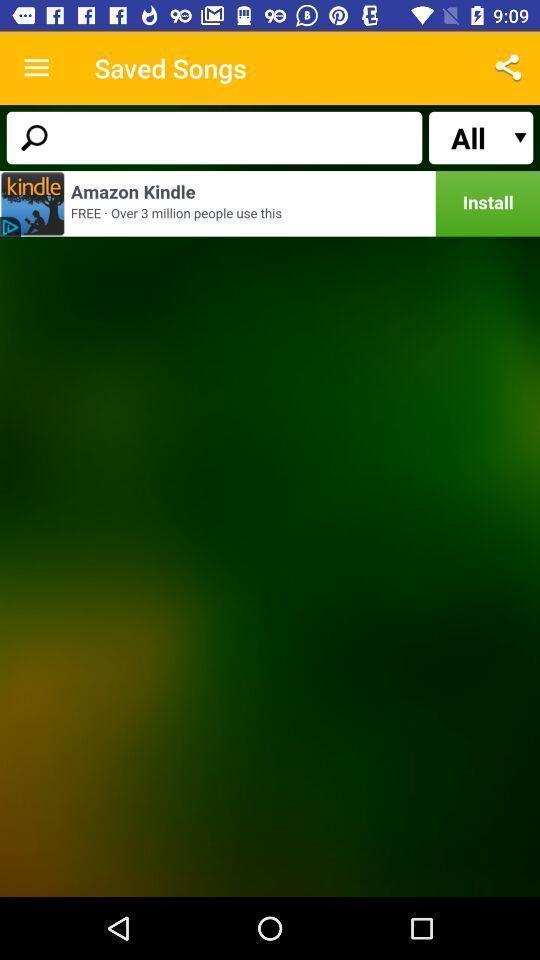Provide a description of this screenshot. Search page of a music app. 